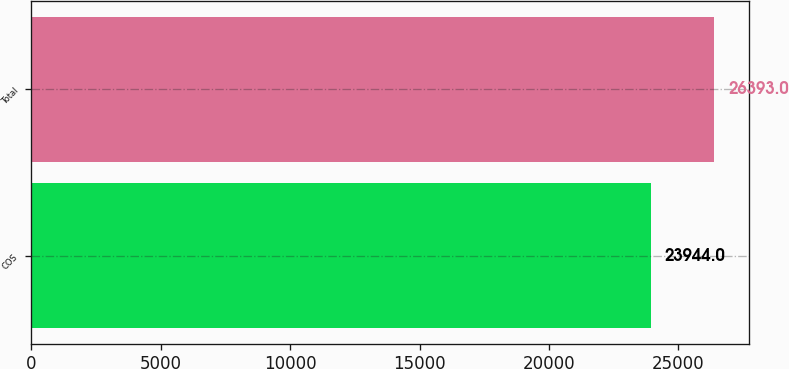<chart> <loc_0><loc_0><loc_500><loc_500><bar_chart><fcel>COS<fcel>Total<nl><fcel>23944<fcel>26393<nl></chart> 